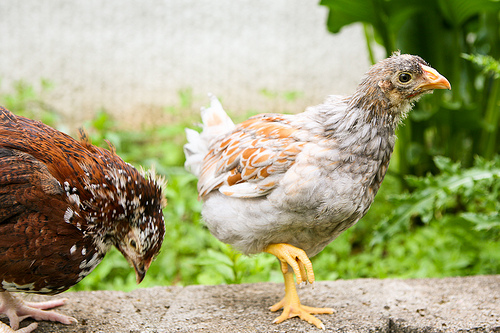<image>
Can you confirm if the hen is to the left of the hen? No. The hen is not to the left of the hen. From this viewpoint, they have a different horizontal relationship. Is there a hen in the grass? No. The hen is not contained within the grass. These objects have a different spatial relationship. Is there a bird in front of the leaves? Yes. The bird is positioned in front of the leaves, appearing closer to the camera viewpoint. 